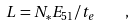<formula> <loc_0><loc_0><loc_500><loc_500>L = N _ { * } E _ { 5 1 } / t _ { e } \quad ,</formula> 